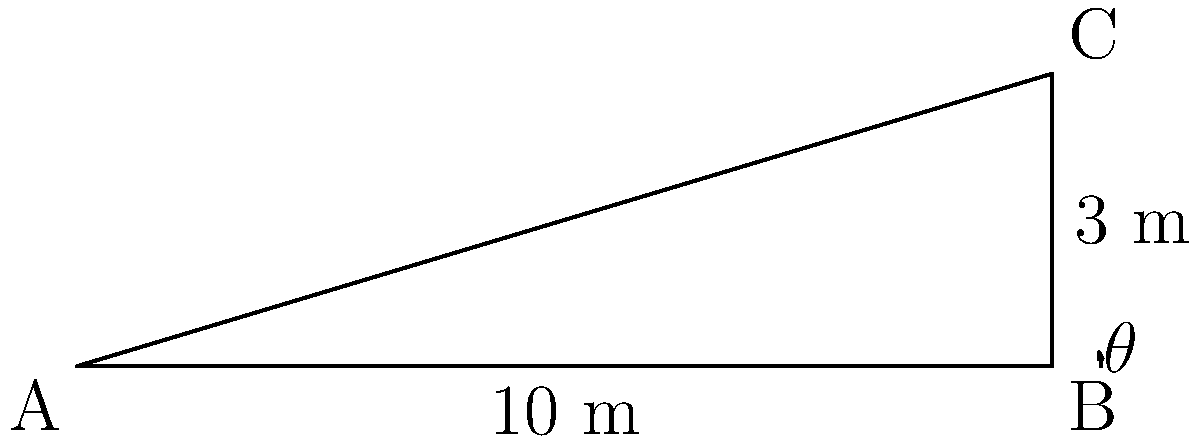A coastal erosion prevention structure is being designed for Santa Monica Beach. The structure has a base length of 10 meters and a height of 3 meters. What is the angle of inclination ($\theta$) of the structure with respect to the horizontal? To find the angle of inclination, we need to use trigonometry. Let's approach this step-by-step:

1) The structure forms a right-angled triangle, where:
   - The base (adjacent side) is 10 meters
   - The height (opposite side) is 3 meters
   - The angle we're looking for is $\theta$

2) In a right-angled triangle, tangent of an angle is the ratio of the opposite side to the adjacent side:

   $\tan(\theta) = \frac{\text{opposite}}{\text{adjacent}} = \frac{\text{height}}{\text{base}}$

3) Substituting our values:

   $\tan(\theta) = \frac{3}{10} = 0.3$

4) To find $\theta$, we need to take the inverse tangent (arctan or $\tan^{-1}$) of both sides:

   $\theta = \tan^{-1}(0.3)$

5) Using a calculator or trigonometric tables:

   $\theta \approx 16.70^\circ$

This angle ensures that the structure is effective in preventing coastal erosion while maintaining stability against ocean forces.
Answer: $16.70^\circ$ 